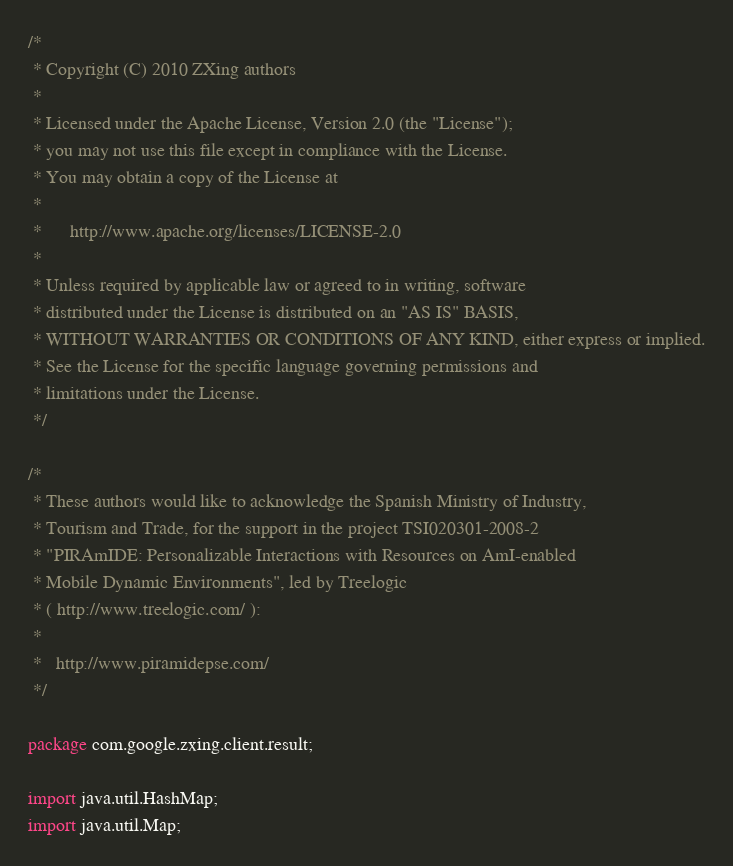<code> <loc_0><loc_0><loc_500><loc_500><_Java_>/*
 * Copyright (C) 2010 ZXing authors
 *
 * Licensed under the Apache License, Version 2.0 (the "License");
 * you may not use this file except in compliance with the License.
 * You may obtain a copy of the License at
 *
 *      http://www.apache.org/licenses/LICENSE-2.0
 *
 * Unless required by applicable law or agreed to in writing, software
 * distributed under the License is distributed on an "AS IS" BASIS,
 * WITHOUT WARRANTIES OR CONDITIONS OF ANY KIND, either express or implied.
 * See the License for the specific language governing permissions and
 * limitations under the License.
 */

/*
 * These authors would like to acknowledge the Spanish Ministry of Industry,
 * Tourism and Trade, for the support in the project TSI020301-2008-2
 * "PIRAmIDE: Personalizable Interactions with Resources on AmI-enabled
 * Mobile Dynamic Environments", led by Treelogic
 * ( http://www.treelogic.com/ ):
 *
 *   http://www.piramidepse.com/
 */

package com.google.zxing.client.result;

import java.util.HashMap;
import java.util.Map;
</code> 